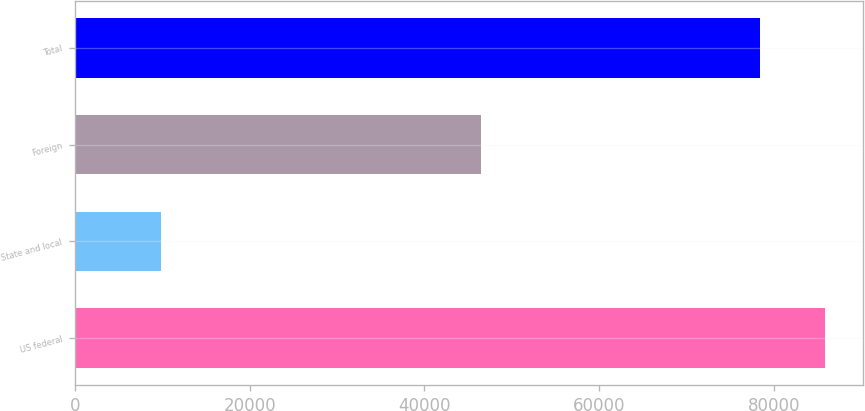<chart> <loc_0><loc_0><loc_500><loc_500><bar_chart><fcel>US federal<fcel>State and local<fcel>Foreign<fcel>Total<nl><fcel>85876.2<fcel>9774<fcel>46450<fcel>78385<nl></chart> 